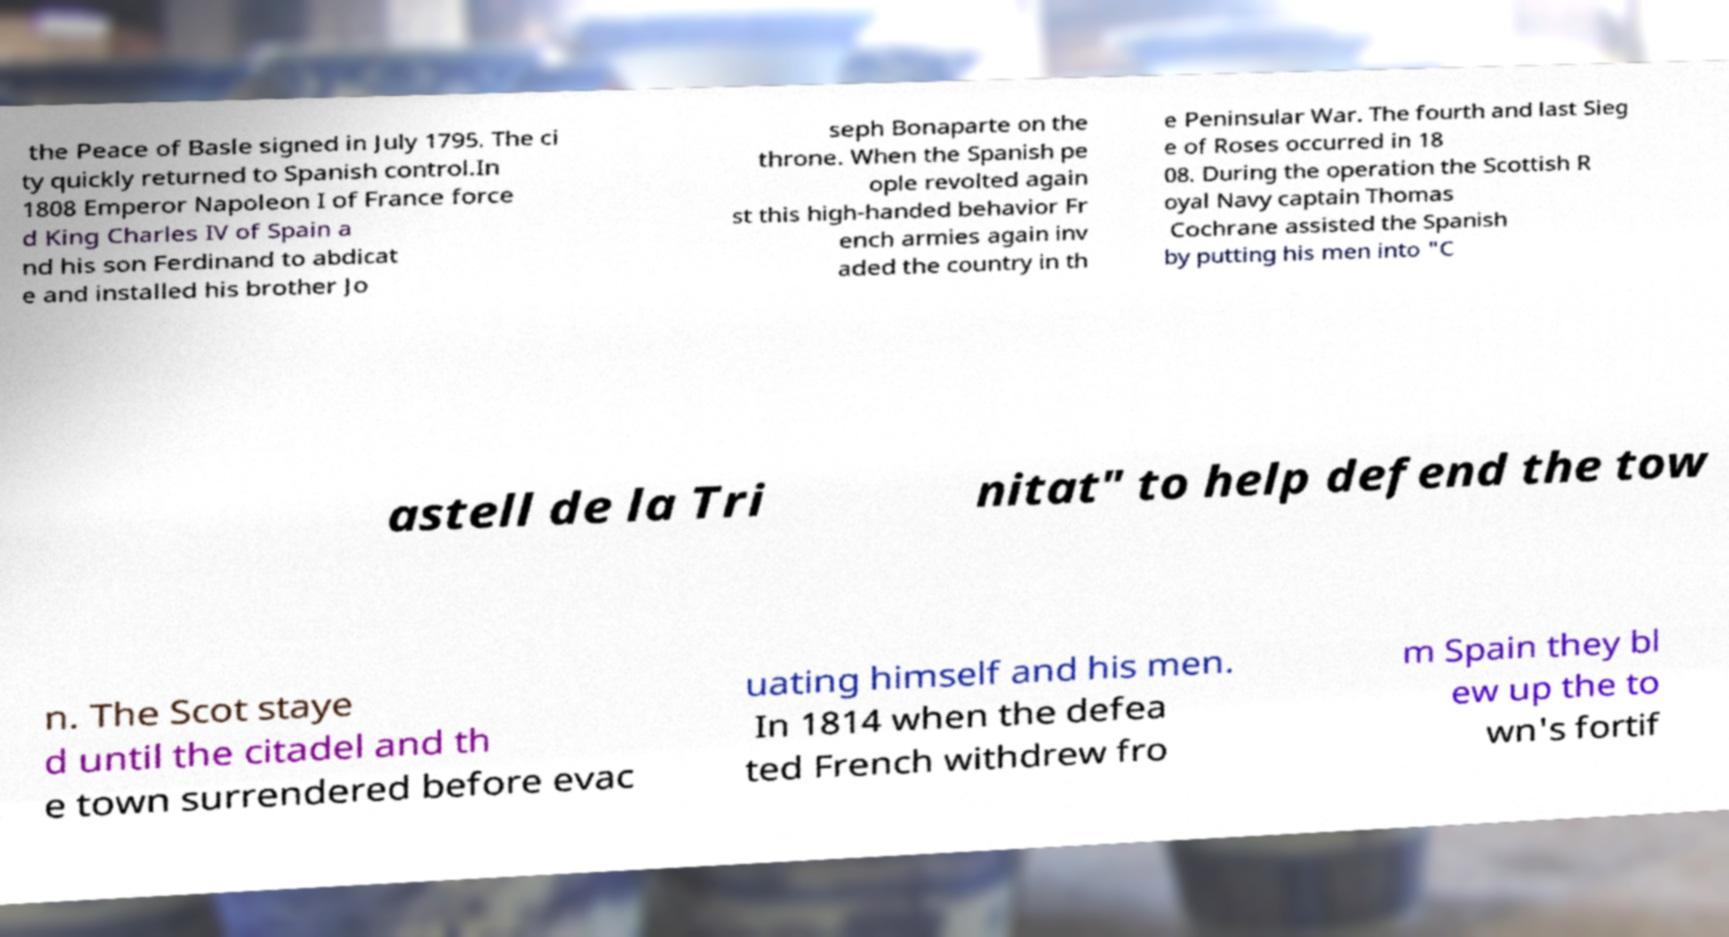Can you read and provide the text displayed in the image?This photo seems to have some interesting text. Can you extract and type it out for me? the Peace of Basle signed in July 1795. The ci ty quickly returned to Spanish control.In 1808 Emperor Napoleon I of France force d King Charles IV of Spain a nd his son Ferdinand to abdicat e and installed his brother Jo seph Bonaparte on the throne. When the Spanish pe ople revolted again st this high-handed behavior Fr ench armies again inv aded the country in th e Peninsular War. The fourth and last Sieg e of Roses occurred in 18 08. During the operation the Scottish R oyal Navy captain Thomas Cochrane assisted the Spanish by putting his men into "C astell de la Tri nitat" to help defend the tow n. The Scot staye d until the citadel and th e town surrendered before evac uating himself and his men. In 1814 when the defea ted French withdrew fro m Spain they bl ew up the to wn's fortif 